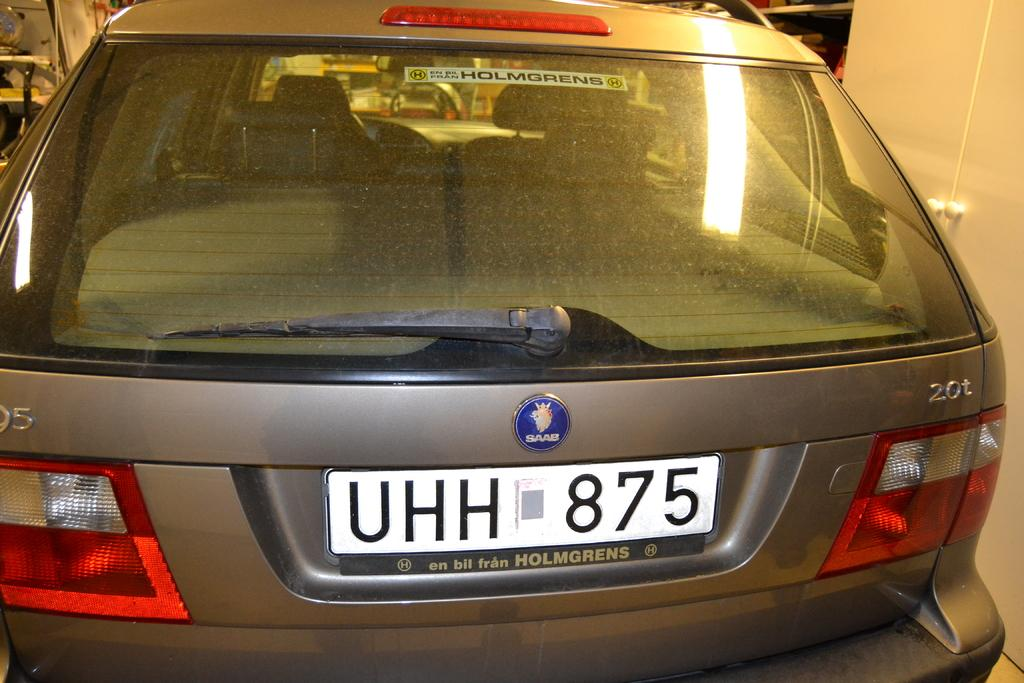<image>
Describe the image concisely. A Saab vehicle that has a white license plate 